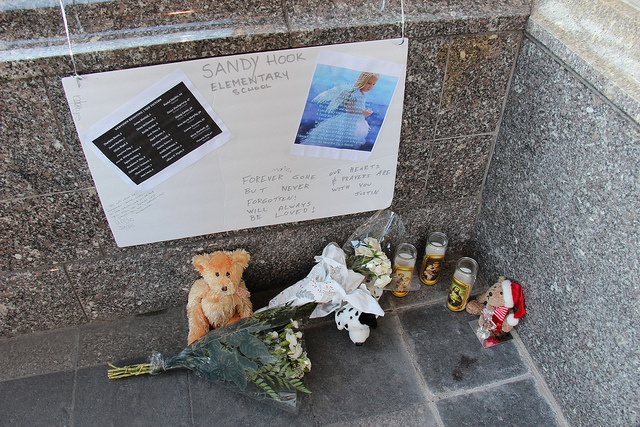Describe the objects in this image and their specific colors. I can see teddy bear in lightgray, tan, and gray tones, teddy bear in lightgray, darkgray, gray, and brown tones, and teddy bear in lightgray, black, and darkgray tones in this image. 